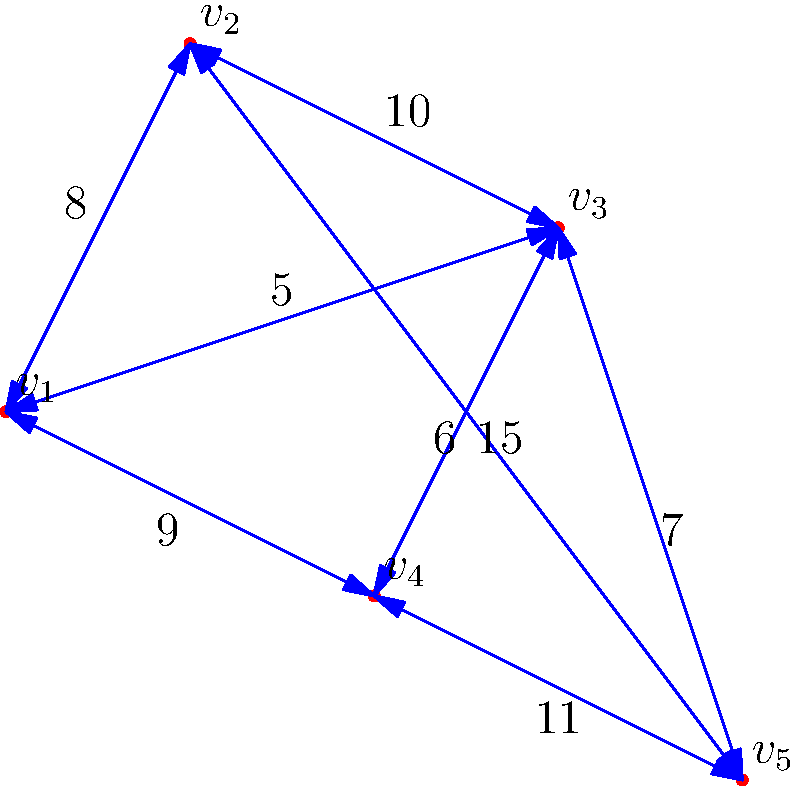A small telecommunications company is planning to install fiber optic cables in a town with five districts, represented by vertices $v_1$ to $v_5$ in the graph. The edges represent possible cable routes between districts, with weights indicating the installation cost in thousands of dollars. What is the minimum total cost (in thousands of dollars) to connect all districts using the minimum spanning tree algorithm? To find the minimum spanning tree (MST) for cost-effective cable installation, we'll use Kruskal's algorithm:

1. Sort all edges by weight (cost) in ascending order:
   (v1, v3): 5
   (v2, v3): 6
   (v2, v4): 7
   (v1, v2): 8
   (v1, v4): 9
   (v1, v5): 10
   (v3, v5): 11
   (v4, v5): 15

2. Start with an empty MST and add edges in order, avoiding cycles:
   - Add (v1, v3): 5
   - Add (v2, v3): 6
   - Add (v2, v4): 7
   - Skip (v1, v2) as it would create a cycle
   - Add (v3, v5): 11

3. The MST is complete with all vertices connected.

4. Sum the weights of the selected edges:
   Total cost = 5 + 6 + 7 + 11 = 29

Therefore, the minimum total cost to connect all districts is 29 thousand dollars.
Answer: $29,000 